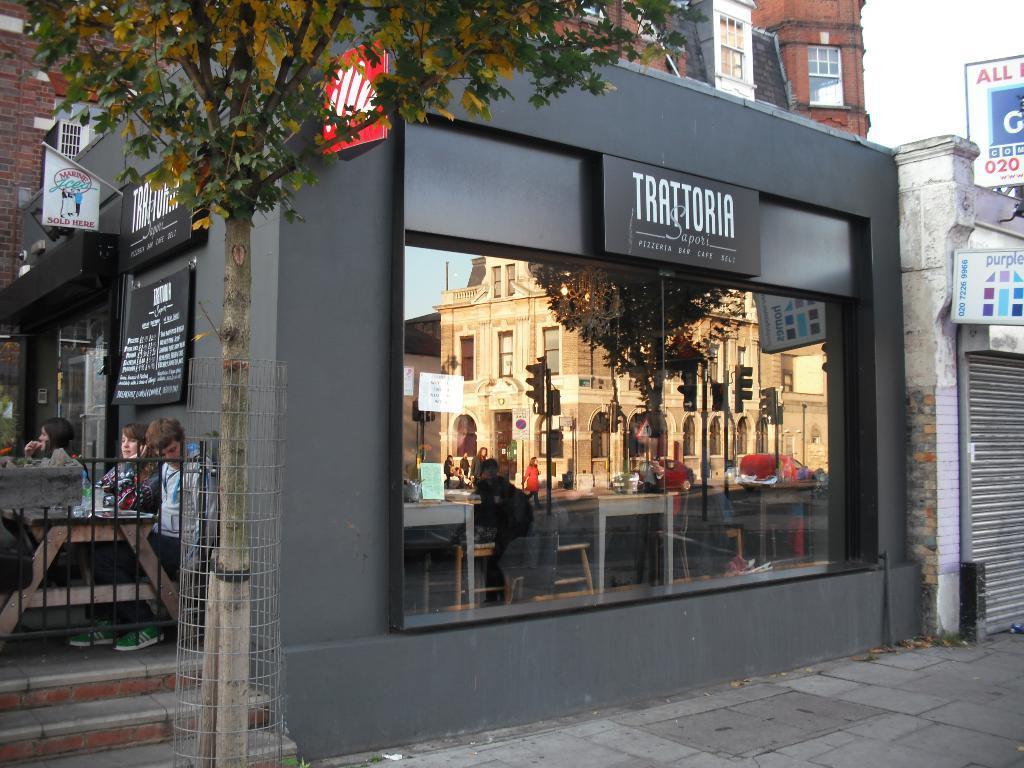Could you give a brief overview of what you see in this image? This is glass. On this glass we can see the reflection of poles, traffic signals, boards, tree, tables, building, and few persons. There are buildings, boards, and few persons. There is a tree. In the background there is sky. 